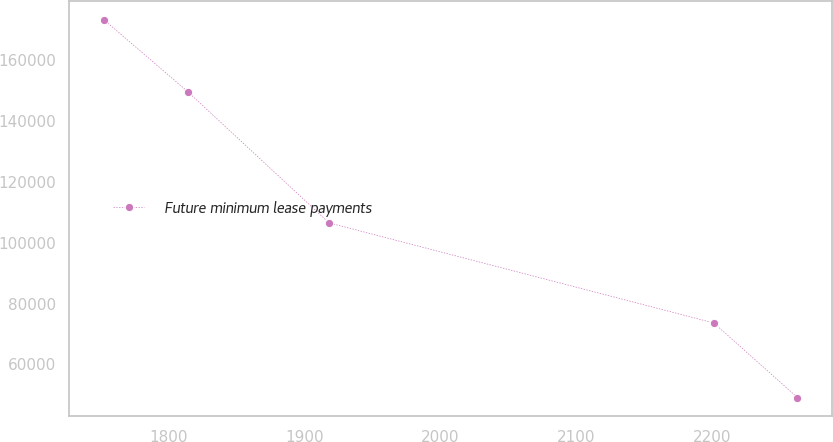Convert chart. <chart><loc_0><loc_0><loc_500><loc_500><line_chart><ecel><fcel>Future minimum lease payments<nl><fcel>1752.23<fcel>173362<nl><fcel>1814.13<fcel>149632<nl><fcel>1918<fcel>106522<nl><fcel>2201.11<fcel>73601.1<nl><fcel>2262.57<fcel>49106.3<nl></chart> 